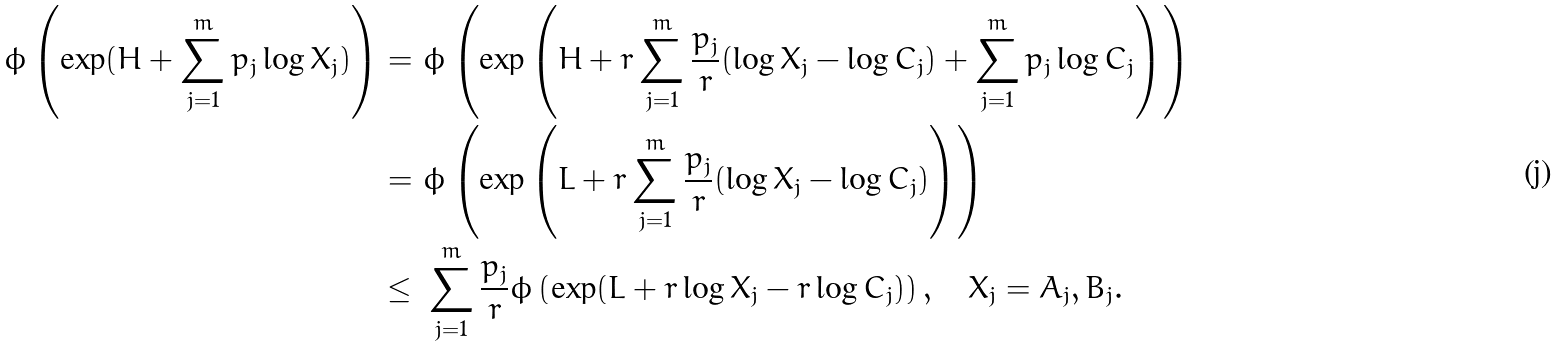Convert formula to latex. <formula><loc_0><loc_0><loc_500><loc_500>\phi \left ( \exp ( H + \sum _ { j = 1 } ^ { m } p _ { j } \log X _ { j } ) \right ) = & \ \phi \left ( \exp \left ( H + r \sum _ { j = 1 } ^ { m } \frac { p _ { j } } { r } ( \log X _ { j } - \log C _ { j } ) + \sum _ { j = 1 } ^ { m } p _ { j } \log C _ { j } \right ) \right ) \\ = & \ \phi \left ( \exp \left ( L + r \sum _ { j = 1 } ^ { m } \frac { p _ { j } } { r } ( \log X _ { j } - \log C _ { j } ) \right ) \right ) \\ \leq & \ \sum _ { j = 1 } ^ { m } \frac { p _ { j } } { r } \phi \left ( \exp ( L + r \log X _ { j } - r \log C _ { j } ) \right ) , \quad X _ { j } = A _ { j } , B _ { j } .</formula> 